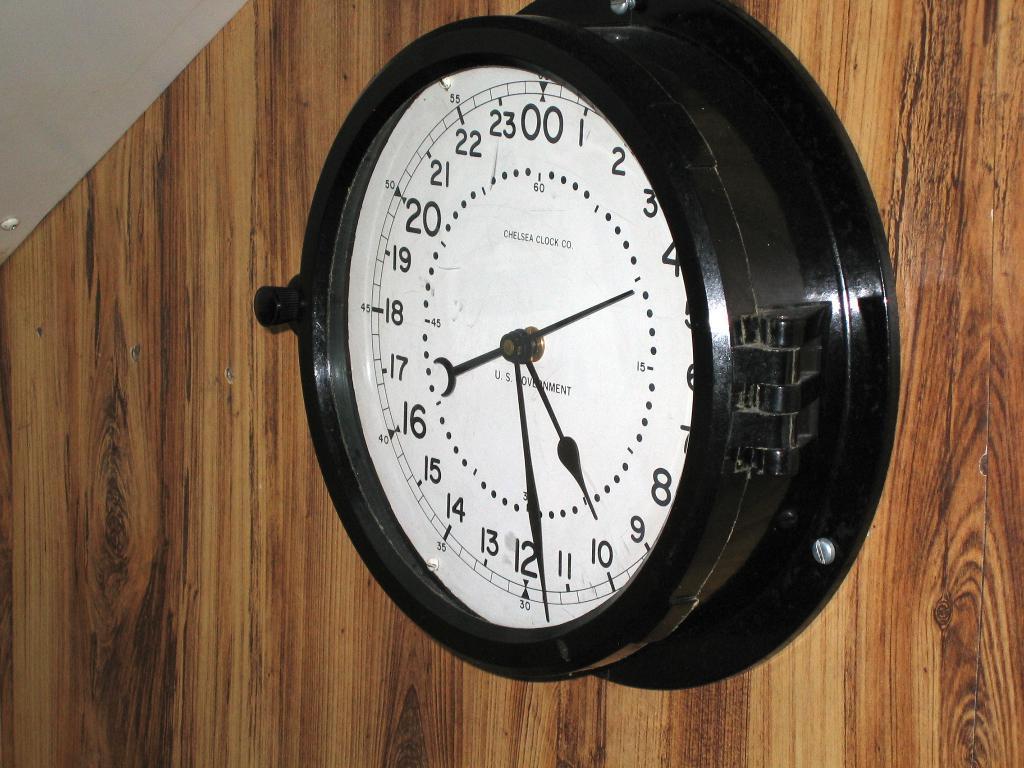Please provide a concise description of this image. In this image there is a wooden wall truncated, there is a wall clock on the wooden wall, there is the roof truncated towards the top of the image, there is an object on the roof. 